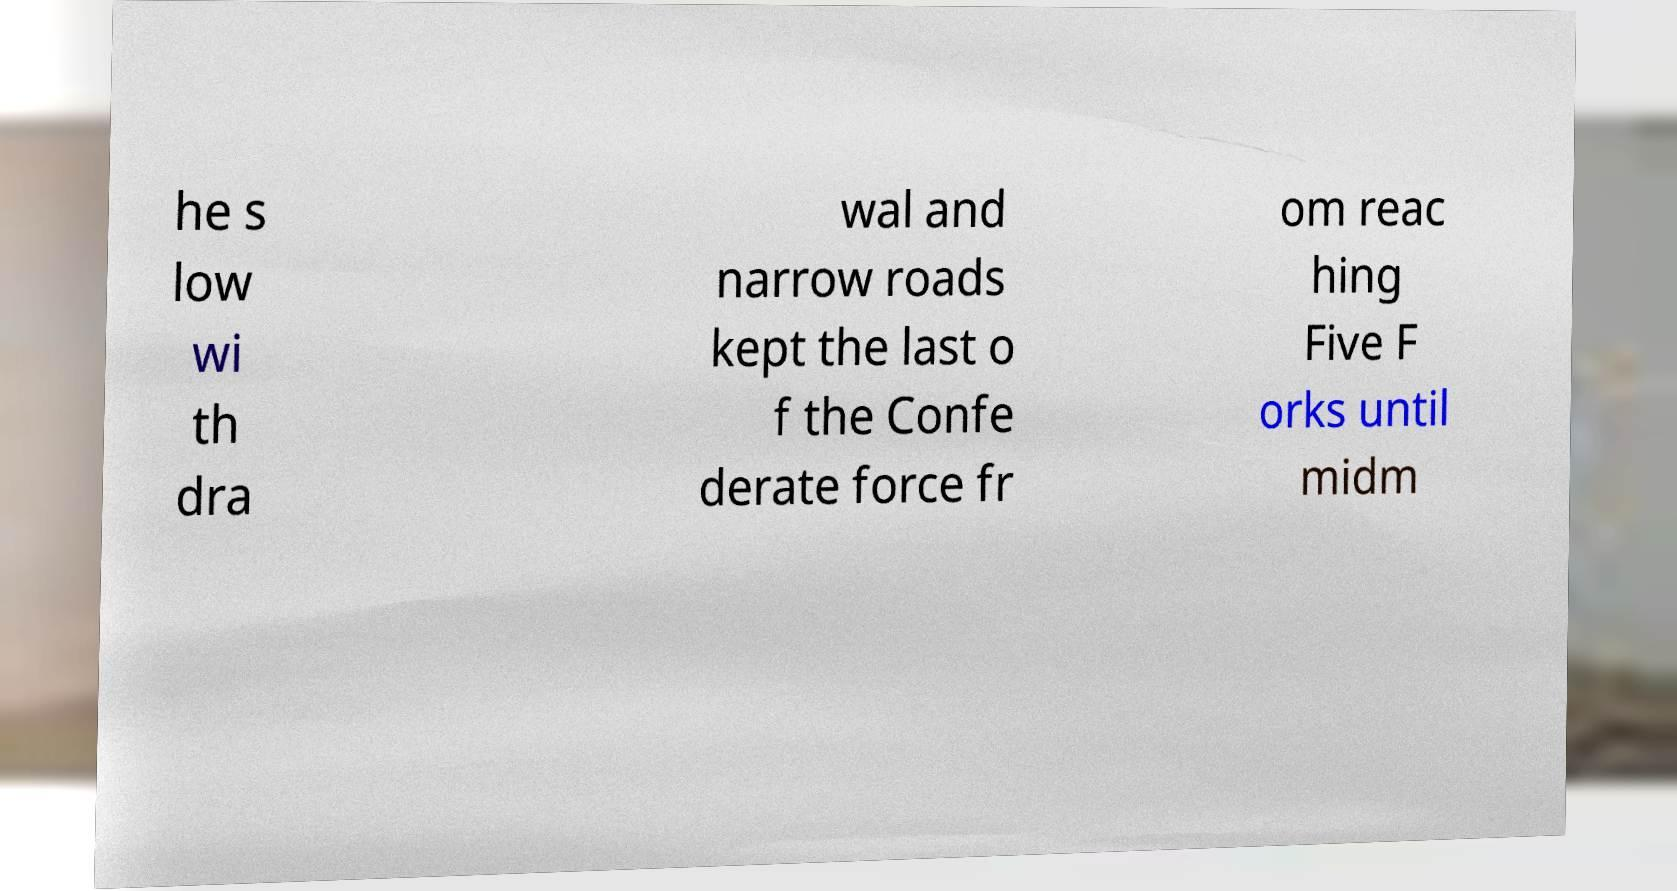What messages or text are displayed in this image? I need them in a readable, typed format. he s low wi th dra wal and narrow roads kept the last o f the Confe derate force fr om reac hing Five F orks until midm 